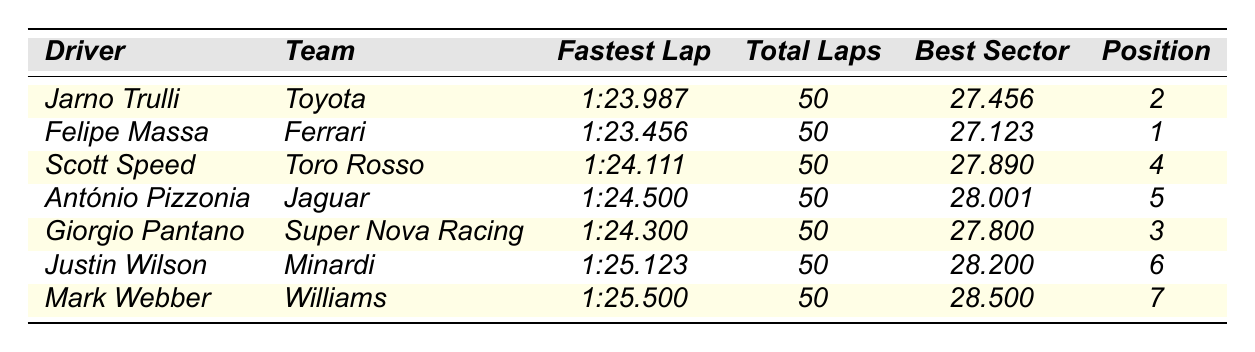What was the fastest lap time achieved during the race? By reviewing the "Fastest Lap" column, the fastest lap time is recorded as 1:23.456.
Answer: 1:23.456 Who finished in third place? Looking at the "Finish Position" column, the driver in the third position is Giorgio Pantano.
Answer: Giorgio Pantano How many drivers had a fastest lap time of over 1:24? Checking the "Fastest Lap" times, Scott Speed (1:24.111), António Pizzonia (1:24.500), and Justin Wilson (1:25.123) all have times over 1:24. Therefore, there are three drivers.
Answer: 3 What is the average best sector time of all drivers? The best sector times are: 27.456, 27.123, 27.890, 28.001, 27.800, 28.200, and 28.500. Adding these gives 27.456 + 27.123 + 27.890 + 28.001 + 27.800 + 28.200 + 28.500 = 28.011. There are 7 times, so the average is 195.971 / 7 ≈ 27.713.
Answer: 27.713 Did any driver complete fewer than 50 laps? The "Total Laps" column shows all drivers completed 50 laps. Thus, the answer is no.
Answer: No Which driver had the best sector time? The best sector time recorded is 27.123 by Felipe Massa, as seen in the "Best Sector Time" column.
Answer: Felipe Massa If we consider only drivers with the fastest lap under 1:24, how many finished in the top 3? The drivers with the fastest laps under 1:24 are Felipe Massa, Jarno Trulli, and Giorgio Pantano. Among them, Felipe Massa (1) and Jarno Trulli (2) finished in the top 3. Thus, there are 2 drivers.
Answer: 2 What was the difference between the fastest lap time and Mark Webber's fastest lap time? The fastest lap time is 1:23.456 and Mark Webber's is 1:25.500. The difference is 2.044 seconds.
Answer: 2.044 seconds 